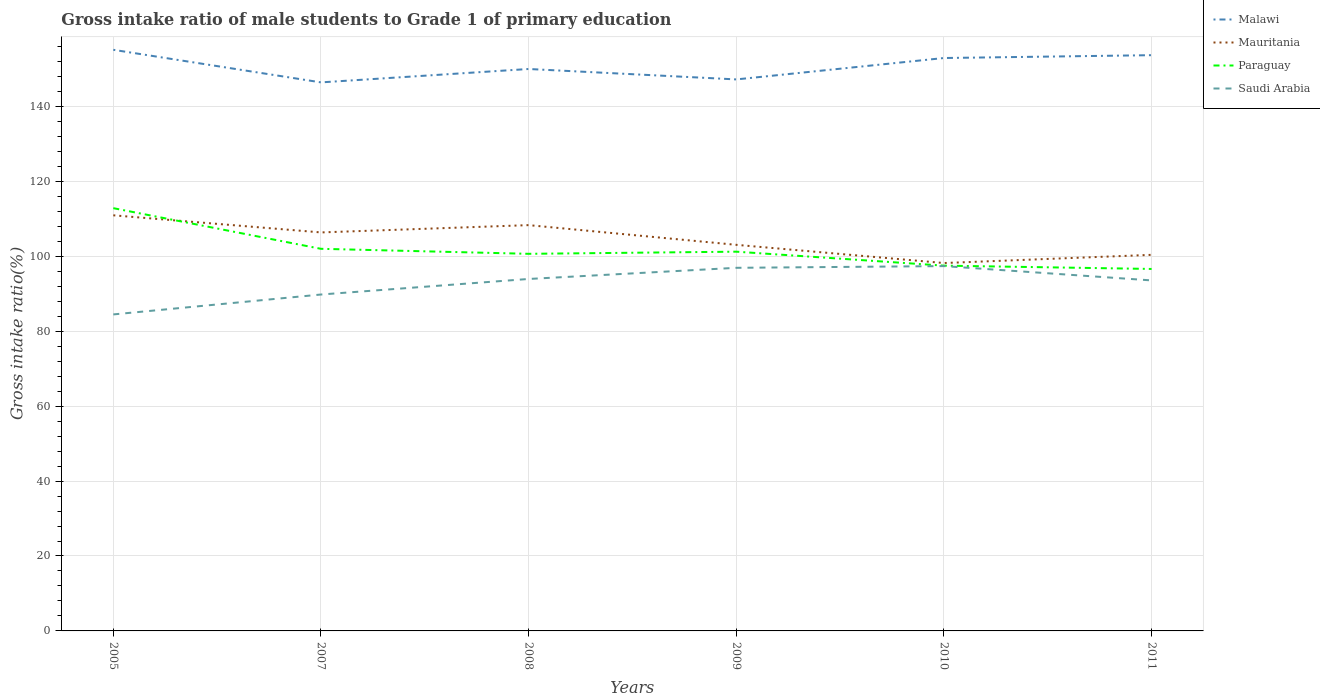How many different coloured lines are there?
Provide a succinct answer. 4. Is the number of lines equal to the number of legend labels?
Make the answer very short. Yes. Across all years, what is the maximum gross intake ratio in Mauritania?
Your response must be concise. 98.2. In which year was the gross intake ratio in Saudi Arabia maximum?
Offer a terse response. 2005. What is the total gross intake ratio in Mauritania in the graph?
Provide a succinct answer. 12.74. What is the difference between the highest and the second highest gross intake ratio in Paraguay?
Provide a succinct answer. 16.23. Is the gross intake ratio in Paraguay strictly greater than the gross intake ratio in Malawi over the years?
Your answer should be very brief. Yes. Does the graph contain any zero values?
Your answer should be very brief. No. How many legend labels are there?
Your response must be concise. 4. What is the title of the graph?
Your answer should be very brief. Gross intake ratio of male students to Grade 1 of primary education. What is the label or title of the X-axis?
Your response must be concise. Years. What is the label or title of the Y-axis?
Your answer should be very brief. Gross intake ratio(%). What is the Gross intake ratio(%) in Malawi in 2005?
Provide a short and direct response. 155.12. What is the Gross intake ratio(%) of Mauritania in 2005?
Offer a terse response. 110.94. What is the Gross intake ratio(%) in Paraguay in 2005?
Make the answer very short. 112.85. What is the Gross intake ratio(%) of Saudi Arabia in 2005?
Make the answer very short. 84.49. What is the Gross intake ratio(%) of Malawi in 2007?
Keep it short and to the point. 146.43. What is the Gross intake ratio(%) in Mauritania in 2007?
Your answer should be compact. 106.37. What is the Gross intake ratio(%) of Paraguay in 2007?
Make the answer very short. 102. What is the Gross intake ratio(%) in Saudi Arabia in 2007?
Give a very brief answer. 89.8. What is the Gross intake ratio(%) in Malawi in 2008?
Your answer should be very brief. 150. What is the Gross intake ratio(%) of Mauritania in 2008?
Make the answer very short. 108.32. What is the Gross intake ratio(%) in Paraguay in 2008?
Your response must be concise. 100.66. What is the Gross intake ratio(%) of Saudi Arabia in 2008?
Ensure brevity in your answer.  93.95. What is the Gross intake ratio(%) of Malawi in 2009?
Provide a succinct answer. 147.22. What is the Gross intake ratio(%) in Mauritania in 2009?
Offer a terse response. 103.06. What is the Gross intake ratio(%) of Paraguay in 2009?
Provide a short and direct response. 101.24. What is the Gross intake ratio(%) of Saudi Arabia in 2009?
Your answer should be very brief. 96.93. What is the Gross intake ratio(%) in Malawi in 2010?
Your answer should be very brief. 152.93. What is the Gross intake ratio(%) of Mauritania in 2010?
Your answer should be very brief. 98.2. What is the Gross intake ratio(%) of Paraguay in 2010?
Provide a succinct answer. 97.51. What is the Gross intake ratio(%) in Saudi Arabia in 2010?
Offer a terse response. 97.39. What is the Gross intake ratio(%) of Malawi in 2011?
Give a very brief answer. 153.69. What is the Gross intake ratio(%) of Mauritania in 2011?
Offer a terse response. 100.39. What is the Gross intake ratio(%) of Paraguay in 2011?
Provide a succinct answer. 96.62. What is the Gross intake ratio(%) in Saudi Arabia in 2011?
Keep it short and to the point. 93.56. Across all years, what is the maximum Gross intake ratio(%) of Malawi?
Ensure brevity in your answer.  155.12. Across all years, what is the maximum Gross intake ratio(%) of Mauritania?
Give a very brief answer. 110.94. Across all years, what is the maximum Gross intake ratio(%) in Paraguay?
Provide a short and direct response. 112.85. Across all years, what is the maximum Gross intake ratio(%) in Saudi Arabia?
Offer a very short reply. 97.39. Across all years, what is the minimum Gross intake ratio(%) in Malawi?
Provide a short and direct response. 146.43. Across all years, what is the minimum Gross intake ratio(%) of Mauritania?
Keep it short and to the point. 98.2. Across all years, what is the minimum Gross intake ratio(%) in Paraguay?
Make the answer very short. 96.62. Across all years, what is the minimum Gross intake ratio(%) in Saudi Arabia?
Give a very brief answer. 84.49. What is the total Gross intake ratio(%) in Malawi in the graph?
Make the answer very short. 905.38. What is the total Gross intake ratio(%) in Mauritania in the graph?
Give a very brief answer. 627.3. What is the total Gross intake ratio(%) in Paraguay in the graph?
Provide a short and direct response. 610.88. What is the total Gross intake ratio(%) in Saudi Arabia in the graph?
Give a very brief answer. 556.11. What is the difference between the Gross intake ratio(%) of Malawi in 2005 and that in 2007?
Give a very brief answer. 8.7. What is the difference between the Gross intake ratio(%) in Mauritania in 2005 and that in 2007?
Your response must be concise. 4.57. What is the difference between the Gross intake ratio(%) in Paraguay in 2005 and that in 2007?
Your answer should be compact. 10.85. What is the difference between the Gross intake ratio(%) in Saudi Arabia in 2005 and that in 2007?
Ensure brevity in your answer.  -5.31. What is the difference between the Gross intake ratio(%) in Malawi in 2005 and that in 2008?
Your response must be concise. 5.12. What is the difference between the Gross intake ratio(%) in Mauritania in 2005 and that in 2008?
Your answer should be very brief. 2.62. What is the difference between the Gross intake ratio(%) of Paraguay in 2005 and that in 2008?
Provide a short and direct response. 12.19. What is the difference between the Gross intake ratio(%) of Saudi Arabia in 2005 and that in 2008?
Your answer should be compact. -9.46. What is the difference between the Gross intake ratio(%) of Malawi in 2005 and that in 2009?
Ensure brevity in your answer.  7.91. What is the difference between the Gross intake ratio(%) of Mauritania in 2005 and that in 2009?
Offer a terse response. 7.88. What is the difference between the Gross intake ratio(%) of Paraguay in 2005 and that in 2009?
Give a very brief answer. 11.62. What is the difference between the Gross intake ratio(%) in Saudi Arabia in 2005 and that in 2009?
Offer a terse response. -12.44. What is the difference between the Gross intake ratio(%) in Malawi in 2005 and that in 2010?
Keep it short and to the point. 2.19. What is the difference between the Gross intake ratio(%) in Mauritania in 2005 and that in 2010?
Ensure brevity in your answer.  12.74. What is the difference between the Gross intake ratio(%) of Paraguay in 2005 and that in 2010?
Your response must be concise. 15.34. What is the difference between the Gross intake ratio(%) of Saudi Arabia in 2005 and that in 2010?
Provide a succinct answer. -12.9. What is the difference between the Gross intake ratio(%) of Malawi in 2005 and that in 2011?
Your answer should be compact. 1.43. What is the difference between the Gross intake ratio(%) in Mauritania in 2005 and that in 2011?
Offer a very short reply. 10.55. What is the difference between the Gross intake ratio(%) of Paraguay in 2005 and that in 2011?
Your answer should be compact. 16.23. What is the difference between the Gross intake ratio(%) of Saudi Arabia in 2005 and that in 2011?
Give a very brief answer. -9.08. What is the difference between the Gross intake ratio(%) in Malawi in 2007 and that in 2008?
Offer a terse response. -3.58. What is the difference between the Gross intake ratio(%) in Mauritania in 2007 and that in 2008?
Offer a terse response. -1.95. What is the difference between the Gross intake ratio(%) in Paraguay in 2007 and that in 2008?
Keep it short and to the point. 1.34. What is the difference between the Gross intake ratio(%) of Saudi Arabia in 2007 and that in 2008?
Your response must be concise. -4.15. What is the difference between the Gross intake ratio(%) in Malawi in 2007 and that in 2009?
Give a very brief answer. -0.79. What is the difference between the Gross intake ratio(%) in Mauritania in 2007 and that in 2009?
Give a very brief answer. 3.31. What is the difference between the Gross intake ratio(%) of Paraguay in 2007 and that in 2009?
Provide a short and direct response. 0.77. What is the difference between the Gross intake ratio(%) in Saudi Arabia in 2007 and that in 2009?
Provide a short and direct response. -7.13. What is the difference between the Gross intake ratio(%) in Malawi in 2007 and that in 2010?
Offer a terse response. -6.5. What is the difference between the Gross intake ratio(%) of Mauritania in 2007 and that in 2010?
Your answer should be compact. 8.17. What is the difference between the Gross intake ratio(%) of Paraguay in 2007 and that in 2010?
Your answer should be compact. 4.49. What is the difference between the Gross intake ratio(%) of Saudi Arabia in 2007 and that in 2010?
Make the answer very short. -7.59. What is the difference between the Gross intake ratio(%) in Malawi in 2007 and that in 2011?
Make the answer very short. -7.26. What is the difference between the Gross intake ratio(%) in Mauritania in 2007 and that in 2011?
Keep it short and to the point. 5.98. What is the difference between the Gross intake ratio(%) of Paraguay in 2007 and that in 2011?
Give a very brief answer. 5.38. What is the difference between the Gross intake ratio(%) of Saudi Arabia in 2007 and that in 2011?
Provide a succinct answer. -3.76. What is the difference between the Gross intake ratio(%) of Malawi in 2008 and that in 2009?
Your answer should be very brief. 2.78. What is the difference between the Gross intake ratio(%) in Mauritania in 2008 and that in 2009?
Ensure brevity in your answer.  5.26. What is the difference between the Gross intake ratio(%) of Paraguay in 2008 and that in 2009?
Make the answer very short. -0.57. What is the difference between the Gross intake ratio(%) in Saudi Arabia in 2008 and that in 2009?
Offer a very short reply. -2.98. What is the difference between the Gross intake ratio(%) of Malawi in 2008 and that in 2010?
Your answer should be compact. -2.93. What is the difference between the Gross intake ratio(%) of Mauritania in 2008 and that in 2010?
Offer a terse response. 10.12. What is the difference between the Gross intake ratio(%) of Paraguay in 2008 and that in 2010?
Give a very brief answer. 3.16. What is the difference between the Gross intake ratio(%) of Saudi Arabia in 2008 and that in 2010?
Your answer should be very brief. -3.44. What is the difference between the Gross intake ratio(%) of Malawi in 2008 and that in 2011?
Your answer should be compact. -3.69. What is the difference between the Gross intake ratio(%) in Mauritania in 2008 and that in 2011?
Make the answer very short. 7.93. What is the difference between the Gross intake ratio(%) in Paraguay in 2008 and that in 2011?
Your answer should be very brief. 4.04. What is the difference between the Gross intake ratio(%) of Saudi Arabia in 2008 and that in 2011?
Your response must be concise. 0.39. What is the difference between the Gross intake ratio(%) in Malawi in 2009 and that in 2010?
Your answer should be very brief. -5.71. What is the difference between the Gross intake ratio(%) of Mauritania in 2009 and that in 2010?
Offer a terse response. 4.86. What is the difference between the Gross intake ratio(%) of Paraguay in 2009 and that in 2010?
Your response must be concise. 3.73. What is the difference between the Gross intake ratio(%) of Saudi Arabia in 2009 and that in 2010?
Make the answer very short. -0.46. What is the difference between the Gross intake ratio(%) of Malawi in 2009 and that in 2011?
Your answer should be very brief. -6.47. What is the difference between the Gross intake ratio(%) in Mauritania in 2009 and that in 2011?
Offer a terse response. 2.67. What is the difference between the Gross intake ratio(%) in Paraguay in 2009 and that in 2011?
Keep it short and to the point. 4.61. What is the difference between the Gross intake ratio(%) in Saudi Arabia in 2009 and that in 2011?
Provide a succinct answer. 3.36. What is the difference between the Gross intake ratio(%) in Malawi in 2010 and that in 2011?
Your answer should be very brief. -0.76. What is the difference between the Gross intake ratio(%) of Mauritania in 2010 and that in 2011?
Provide a short and direct response. -2.19. What is the difference between the Gross intake ratio(%) in Paraguay in 2010 and that in 2011?
Provide a succinct answer. 0.88. What is the difference between the Gross intake ratio(%) of Saudi Arabia in 2010 and that in 2011?
Your answer should be compact. 3.82. What is the difference between the Gross intake ratio(%) of Malawi in 2005 and the Gross intake ratio(%) of Mauritania in 2007?
Make the answer very short. 48.75. What is the difference between the Gross intake ratio(%) in Malawi in 2005 and the Gross intake ratio(%) in Paraguay in 2007?
Provide a succinct answer. 53.12. What is the difference between the Gross intake ratio(%) of Malawi in 2005 and the Gross intake ratio(%) of Saudi Arabia in 2007?
Keep it short and to the point. 65.32. What is the difference between the Gross intake ratio(%) in Mauritania in 2005 and the Gross intake ratio(%) in Paraguay in 2007?
Your answer should be very brief. 8.94. What is the difference between the Gross intake ratio(%) of Mauritania in 2005 and the Gross intake ratio(%) of Saudi Arabia in 2007?
Offer a terse response. 21.14. What is the difference between the Gross intake ratio(%) in Paraguay in 2005 and the Gross intake ratio(%) in Saudi Arabia in 2007?
Provide a succinct answer. 23.05. What is the difference between the Gross intake ratio(%) in Malawi in 2005 and the Gross intake ratio(%) in Mauritania in 2008?
Provide a short and direct response. 46.8. What is the difference between the Gross intake ratio(%) in Malawi in 2005 and the Gross intake ratio(%) in Paraguay in 2008?
Offer a terse response. 54.46. What is the difference between the Gross intake ratio(%) of Malawi in 2005 and the Gross intake ratio(%) of Saudi Arabia in 2008?
Provide a short and direct response. 61.17. What is the difference between the Gross intake ratio(%) in Mauritania in 2005 and the Gross intake ratio(%) in Paraguay in 2008?
Your response must be concise. 10.28. What is the difference between the Gross intake ratio(%) of Mauritania in 2005 and the Gross intake ratio(%) of Saudi Arabia in 2008?
Offer a terse response. 16.99. What is the difference between the Gross intake ratio(%) of Paraguay in 2005 and the Gross intake ratio(%) of Saudi Arabia in 2008?
Offer a very short reply. 18.9. What is the difference between the Gross intake ratio(%) of Malawi in 2005 and the Gross intake ratio(%) of Mauritania in 2009?
Provide a succinct answer. 52.06. What is the difference between the Gross intake ratio(%) of Malawi in 2005 and the Gross intake ratio(%) of Paraguay in 2009?
Your answer should be compact. 53.89. What is the difference between the Gross intake ratio(%) in Malawi in 2005 and the Gross intake ratio(%) in Saudi Arabia in 2009?
Offer a very short reply. 58.19. What is the difference between the Gross intake ratio(%) in Mauritania in 2005 and the Gross intake ratio(%) in Paraguay in 2009?
Offer a very short reply. 9.71. What is the difference between the Gross intake ratio(%) in Mauritania in 2005 and the Gross intake ratio(%) in Saudi Arabia in 2009?
Keep it short and to the point. 14.02. What is the difference between the Gross intake ratio(%) of Paraguay in 2005 and the Gross intake ratio(%) of Saudi Arabia in 2009?
Your response must be concise. 15.92. What is the difference between the Gross intake ratio(%) in Malawi in 2005 and the Gross intake ratio(%) in Mauritania in 2010?
Give a very brief answer. 56.92. What is the difference between the Gross intake ratio(%) of Malawi in 2005 and the Gross intake ratio(%) of Paraguay in 2010?
Provide a succinct answer. 57.62. What is the difference between the Gross intake ratio(%) in Malawi in 2005 and the Gross intake ratio(%) in Saudi Arabia in 2010?
Your answer should be compact. 57.74. What is the difference between the Gross intake ratio(%) in Mauritania in 2005 and the Gross intake ratio(%) in Paraguay in 2010?
Offer a terse response. 13.44. What is the difference between the Gross intake ratio(%) in Mauritania in 2005 and the Gross intake ratio(%) in Saudi Arabia in 2010?
Your answer should be very brief. 13.56. What is the difference between the Gross intake ratio(%) in Paraguay in 2005 and the Gross intake ratio(%) in Saudi Arabia in 2010?
Provide a short and direct response. 15.46. What is the difference between the Gross intake ratio(%) in Malawi in 2005 and the Gross intake ratio(%) in Mauritania in 2011?
Provide a short and direct response. 54.73. What is the difference between the Gross intake ratio(%) of Malawi in 2005 and the Gross intake ratio(%) of Paraguay in 2011?
Ensure brevity in your answer.  58.5. What is the difference between the Gross intake ratio(%) in Malawi in 2005 and the Gross intake ratio(%) in Saudi Arabia in 2011?
Make the answer very short. 61.56. What is the difference between the Gross intake ratio(%) of Mauritania in 2005 and the Gross intake ratio(%) of Paraguay in 2011?
Offer a terse response. 14.32. What is the difference between the Gross intake ratio(%) in Mauritania in 2005 and the Gross intake ratio(%) in Saudi Arabia in 2011?
Offer a very short reply. 17.38. What is the difference between the Gross intake ratio(%) in Paraguay in 2005 and the Gross intake ratio(%) in Saudi Arabia in 2011?
Provide a short and direct response. 19.29. What is the difference between the Gross intake ratio(%) of Malawi in 2007 and the Gross intake ratio(%) of Mauritania in 2008?
Your answer should be very brief. 38.1. What is the difference between the Gross intake ratio(%) of Malawi in 2007 and the Gross intake ratio(%) of Paraguay in 2008?
Provide a succinct answer. 45.76. What is the difference between the Gross intake ratio(%) in Malawi in 2007 and the Gross intake ratio(%) in Saudi Arabia in 2008?
Ensure brevity in your answer.  52.48. What is the difference between the Gross intake ratio(%) in Mauritania in 2007 and the Gross intake ratio(%) in Paraguay in 2008?
Provide a short and direct response. 5.71. What is the difference between the Gross intake ratio(%) in Mauritania in 2007 and the Gross intake ratio(%) in Saudi Arabia in 2008?
Keep it short and to the point. 12.42. What is the difference between the Gross intake ratio(%) of Paraguay in 2007 and the Gross intake ratio(%) of Saudi Arabia in 2008?
Your answer should be very brief. 8.05. What is the difference between the Gross intake ratio(%) of Malawi in 2007 and the Gross intake ratio(%) of Mauritania in 2009?
Make the answer very short. 43.36. What is the difference between the Gross intake ratio(%) in Malawi in 2007 and the Gross intake ratio(%) in Paraguay in 2009?
Make the answer very short. 45.19. What is the difference between the Gross intake ratio(%) of Malawi in 2007 and the Gross intake ratio(%) of Saudi Arabia in 2009?
Offer a terse response. 49.5. What is the difference between the Gross intake ratio(%) in Mauritania in 2007 and the Gross intake ratio(%) in Paraguay in 2009?
Make the answer very short. 5.14. What is the difference between the Gross intake ratio(%) in Mauritania in 2007 and the Gross intake ratio(%) in Saudi Arabia in 2009?
Give a very brief answer. 9.45. What is the difference between the Gross intake ratio(%) in Paraguay in 2007 and the Gross intake ratio(%) in Saudi Arabia in 2009?
Make the answer very short. 5.07. What is the difference between the Gross intake ratio(%) of Malawi in 2007 and the Gross intake ratio(%) of Mauritania in 2010?
Your response must be concise. 48.22. What is the difference between the Gross intake ratio(%) in Malawi in 2007 and the Gross intake ratio(%) in Paraguay in 2010?
Provide a succinct answer. 48.92. What is the difference between the Gross intake ratio(%) of Malawi in 2007 and the Gross intake ratio(%) of Saudi Arabia in 2010?
Your answer should be very brief. 49.04. What is the difference between the Gross intake ratio(%) of Mauritania in 2007 and the Gross intake ratio(%) of Paraguay in 2010?
Provide a short and direct response. 8.87. What is the difference between the Gross intake ratio(%) of Mauritania in 2007 and the Gross intake ratio(%) of Saudi Arabia in 2010?
Offer a terse response. 8.99. What is the difference between the Gross intake ratio(%) of Paraguay in 2007 and the Gross intake ratio(%) of Saudi Arabia in 2010?
Keep it short and to the point. 4.61. What is the difference between the Gross intake ratio(%) of Malawi in 2007 and the Gross intake ratio(%) of Mauritania in 2011?
Your answer should be compact. 46.03. What is the difference between the Gross intake ratio(%) in Malawi in 2007 and the Gross intake ratio(%) in Paraguay in 2011?
Provide a succinct answer. 49.8. What is the difference between the Gross intake ratio(%) in Malawi in 2007 and the Gross intake ratio(%) in Saudi Arabia in 2011?
Keep it short and to the point. 52.86. What is the difference between the Gross intake ratio(%) in Mauritania in 2007 and the Gross intake ratio(%) in Paraguay in 2011?
Provide a short and direct response. 9.75. What is the difference between the Gross intake ratio(%) of Mauritania in 2007 and the Gross intake ratio(%) of Saudi Arabia in 2011?
Your answer should be very brief. 12.81. What is the difference between the Gross intake ratio(%) of Paraguay in 2007 and the Gross intake ratio(%) of Saudi Arabia in 2011?
Ensure brevity in your answer.  8.44. What is the difference between the Gross intake ratio(%) in Malawi in 2008 and the Gross intake ratio(%) in Mauritania in 2009?
Offer a terse response. 46.94. What is the difference between the Gross intake ratio(%) in Malawi in 2008 and the Gross intake ratio(%) in Paraguay in 2009?
Make the answer very short. 48.77. What is the difference between the Gross intake ratio(%) in Malawi in 2008 and the Gross intake ratio(%) in Saudi Arabia in 2009?
Provide a short and direct response. 53.07. What is the difference between the Gross intake ratio(%) in Mauritania in 2008 and the Gross intake ratio(%) in Paraguay in 2009?
Your answer should be compact. 7.09. What is the difference between the Gross intake ratio(%) in Mauritania in 2008 and the Gross intake ratio(%) in Saudi Arabia in 2009?
Provide a short and direct response. 11.39. What is the difference between the Gross intake ratio(%) of Paraguay in 2008 and the Gross intake ratio(%) of Saudi Arabia in 2009?
Make the answer very short. 3.74. What is the difference between the Gross intake ratio(%) of Malawi in 2008 and the Gross intake ratio(%) of Mauritania in 2010?
Your answer should be compact. 51.8. What is the difference between the Gross intake ratio(%) of Malawi in 2008 and the Gross intake ratio(%) of Paraguay in 2010?
Offer a terse response. 52.49. What is the difference between the Gross intake ratio(%) of Malawi in 2008 and the Gross intake ratio(%) of Saudi Arabia in 2010?
Offer a very short reply. 52.62. What is the difference between the Gross intake ratio(%) of Mauritania in 2008 and the Gross intake ratio(%) of Paraguay in 2010?
Offer a very short reply. 10.82. What is the difference between the Gross intake ratio(%) of Mauritania in 2008 and the Gross intake ratio(%) of Saudi Arabia in 2010?
Make the answer very short. 10.94. What is the difference between the Gross intake ratio(%) of Paraguay in 2008 and the Gross intake ratio(%) of Saudi Arabia in 2010?
Your answer should be very brief. 3.28. What is the difference between the Gross intake ratio(%) of Malawi in 2008 and the Gross intake ratio(%) of Mauritania in 2011?
Ensure brevity in your answer.  49.61. What is the difference between the Gross intake ratio(%) of Malawi in 2008 and the Gross intake ratio(%) of Paraguay in 2011?
Provide a short and direct response. 53.38. What is the difference between the Gross intake ratio(%) in Malawi in 2008 and the Gross intake ratio(%) in Saudi Arabia in 2011?
Keep it short and to the point. 56.44. What is the difference between the Gross intake ratio(%) of Mauritania in 2008 and the Gross intake ratio(%) of Paraguay in 2011?
Give a very brief answer. 11.7. What is the difference between the Gross intake ratio(%) in Mauritania in 2008 and the Gross intake ratio(%) in Saudi Arabia in 2011?
Your response must be concise. 14.76. What is the difference between the Gross intake ratio(%) of Paraguay in 2008 and the Gross intake ratio(%) of Saudi Arabia in 2011?
Make the answer very short. 7.1. What is the difference between the Gross intake ratio(%) in Malawi in 2009 and the Gross intake ratio(%) in Mauritania in 2010?
Keep it short and to the point. 49.01. What is the difference between the Gross intake ratio(%) of Malawi in 2009 and the Gross intake ratio(%) of Paraguay in 2010?
Ensure brevity in your answer.  49.71. What is the difference between the Gross intake ratio(%) in Malawi in 2009 and the Gross intake ratio(%) in Saudi Arabia in 2010?
Provide a short and direct response. 49.83. What is the difference between the Gross intake ratio(%) of Mauritania in 2009 and the Gross intake ratio(%) of Paraguay in 2010?
Offer a terse response. 5.56. What is the difference between the Gross intake ratio(%) in Mauritania in 2009 and the Gross intake ratio(%) in Saudi Arabia in 2010?
Your response must be concise. 5.68. What is the difference between the Gross intake ratio(%) in Paraguay in 2009 and the Gross intake ratio(%) in Saudi Arabia in 2010?
Your response must be concise. 3.85. What is the difference between the Gross intake ratio(%) in Malawi in 2009 and the Gross intake ratio(%) in Mauritania in 2011?
Ensure brevity in your answer.  46.83. What is the difference between the Gross intake ratio(%) in Malawi in 2009 and the Gross intake ratio(%) in Paraguay in 2011?
Offer a terse response. 50.59. What is the difference between the Gross intake ratio(%) in Malawi in 2009 and the Gross intake ratio(%) in Saudi Arabia in 2011?
Keep it short and to the point. 53.65. What is the difference between the Gross intake ratio(%) of Mauritania in 2009 and the Gross intake ratio(%) of Paraguay in 2011?
Provide a succinct answer. 6.44. What is the difference between the Gross intake ratio(%) in Mauritania in 2009 and the Gross intake ratio(%) in Saudi Arabia in 2011?
Your response must be concise. 9.5. What is the difference between the Gross intake ratio(%) in Paraguay in 2009 and the Gross intake ratio(%) in Saudi Arabia in 2011?
Provide a succinct answer. 7.67. What is the difference between the Gross intake ratio(%) of Malawi in 2010 and the Gross intake ratio(%) of Mauritania in 2011?
Make the answer very short. 52.54. What is the difference between the Gross intake ratio(%) of Malawi in 2010 and the Gross intake ratio(%) of Paraguay in 2011?
Your response must be concise. 56.31. What is the difference between the Gross intake ratio(%) in Malawi in 2010 and the Gross intake ratio(%) in Saudi Arabia in 2011?
Make the answer very short. 59.37. What is the difference between the Gross intake ratio(%) of Mauritania in 2010 and the Gross intake ratio(%) of Paraguay in 2011?
Offer a very short reply. 1.58. What is the difference between the Gross intake ratio(%) in Mauritania in 2010 and the Gross intake ratio(%) in Saudi Arabia in 2011?
Ensure brevity in your answer.  4.64. What is the difference between the Gross intake ratio(%) in Paraguay in 2010 and the Gross intake ratio(%) in Saudi Arabia in 2011?
Your answer should be very brief. 3.94. What is the average Gross intake ratio(%) in Malawi per year?
Offer a terse response. 150.9. What is the average Gross intake ratio(%) in Mauritania per year?
Your answer should be very brief. 104.55. What is the average Gross intake ratio(%) of Paraguay per year?
Offer a terse response. 101.81. What is the average Gross intake ratio(%) of Saudi Arabia per year?
Provide a succinct answer. 92.69. In the year 2005, what is the difference between the Gross intake ratio(%) of Malawi and Gross intake ratio(%) of Mauritania?
Your answer should be very brief. 44.18. In the year 2005, what is the difference between the Gross intake ratio(%) in Malawi and Gross intake ratio(%) in Paraguay?
Provide a succinct answer. 42.27. In the year 2005, what is the difference between the Gross intake ratio(%) of Malawi and Gross intake ratio(%) of Saudi Arabia?
Keep it short and to the point. 70.64. In the year 2005, what is the difference between the Gross intake ratio(%) of Mauritania and Gross intake ratio(%) of Paraguay?
Offer a terse response. -1.91. In the year 2005, what is the difference between the Gross intake ratio(%) of Mauritania and Gross intake ratio(%) of Saudi Arabia?
Your response must be concise. 26.46. In the year 2005, what is the difference between the Gross intake ratio(%) of Paraguay and Gross intake ratio(%) of Saudi Arabia?
Keep it short and to the point. 28.36. In the year 2007, what is the difference between the Gross intake ratio(%) of Malawi and Gross intake ratio(%) of Mauritania?
Provide a succinct answer. 40.05. In the year 2007, what is the difference between the Gross intake ratio(%) of Malawi and Gross intake ratio(%) of Paraguay?
Offer a terse response. 44.42. In the year 2007, what is the difference between the Gross intake ratio(%) in Malawi and Gross intake ratio(%) in Saudi Arabia?
Your response must be concise. 56.63. In the year 2007, what is the difference between the Gross intake ratio(%) in Mauritania and Gross intake ratio(%) in Paraguay?
Provide a short and direct response. 4.37. In the year 2007, what is the difference between the Gross intake ratio(%) in Mauritania and Gross intake ratio(%) in Saudi Arabia?
Give a very brief answer. 16.57. In the year 2007, what is the difference between the Gross intake ratio(%) in Paraguay and Gross intake ratio(%) in Saudi Arabia?
Provide a succinct answer. 12.2. In the year 2008, what is the difference between the Gross intake ratio(%) of Malawi and Gross intake ratio(%) of Mauritania?
Offer a very short reply. 41.68. In the year 2008, what is the difference between the Gross intake ratio(%) of Malawi and Gross intake ratio(%) of Paraguay?
Keep it short and to the point. 49.34. In the year 2008, what is the difference between the Gross intake ratio(%) in Malawi and Gross intake ratio(%) in Saudi Arabia?
Your response must be concise. 56.05. In the year 2008, what is the difference between the Gross intake ratio(%) of Mauritania and Gross intake ratio(%) of Paraguay?
Offer a terse response. 7.66. In the year 2008, what is the difference between the Gross intake ratio(%) in Mauritania and Gross intake ratio(%) in Saudi Arabia?
Make the answer very short. 14.37. In the year 2008, what is the difference between the Gross intake ratio(%) in Paraguay and Gross intake ratio(%) in Saudi Arabia?
Offer a very short reply. 6.71. In the year 2009, what is the difference between the Gross intake ratio(%) of Malawi and Gross intake ratio(%) of Mauritania?
Ensure brevity in your answer.  44.15. In the year 2009, what is the difference between the Gross intake ratio(%) in Malawi and Gross intake ratio(%) in Paraguay?
Offer a terse response. 45.98. In the year 2009, what is the difference between the Gross intake ratio(%) of Malawi and Gross intake ratio(%) of Saudi Arabia?
Make the answer very short. 50.29. In the year 2009, what is the difference between the Gross intake ratio(%) of Mauritania and Gross intake ratio(%) of Paraguay?
Provide a short and direct response. 1.83. In the year 2009, what is the difference between the Gross intake ratio(%) of Mauritania and Gross intake ratio(%) of Saudi Arabia?
Your answer should be very brief. 6.14. In the year 2009, what is the difference between the Gross intake ratio(%) in Paraguay and Gross intake ratio(%) in Saudi Arabia?
Your answer should be very brief. 4.31. In the year 2010, what is the difference between the Gross intake ratio(%) of Malawi and Gross intake ratio(%) of Mauritania?
Your answer should be very brief. 54.73. In the year 2010, what is the difference between the Gross intake ratio(%) of Malawi and Gross intake ratio(%) of Paraguay?
Your answer should be compact. 55.42. In the year 2010, what is the difference between the Gross intake ratio(%) of Malawi and Gross intake ratio(%) of Saudi Arabia?
Provide a short and direct response. 55.54. In the year 2010, what is the difference between the Gross intake ratio(%) of Mauritania and Gross intake ratio(%) of Paraguay?
Give a very brief answer. 0.7. In the year 2010, what is the difference between the Gross intake ratio(%) of Mauritania and Gross intake ratio(%) of Saudi Arabia?
Ensure brevity in your answer.  0.82. In the year 2010, what is the difference between the Gross intake ratio(%) in Paraguay and Gross intake ratio(%) in Saudi Arabia?
Offer a terse response. 0.12. In the year 2011, what is the difference between the Gross intake ratio(%) of Malawi and Gross intake ratio(%) of Mauritania?
Offer a terse response. 53.3. In the year 2011, what is the difference between the Gross intake ratio(%) in Malawi and Gross intake ratio(%) in Paraguay?
Offer a terse response. 57.07. In the year 2011, what is the difference between the Gross intake ratio(%) of Malawi and Gross intake ratio(%) of Saudi Arabia?
Your answer should be compact. 60.12. In the year 2011, what is the difference between the Gross intake ratio(%) of Mauritania and Gross intake ratio(%) of Paraguay?
Ensure brevity in your answer.  3.77. In the year 2011, what is the difference between the Gross intake ratio(%) in Mauritania and Gross intake ratio(%) in Saudi Arabia?
Keep it short and to the point. 6.83. In the year 2011, what is the difference between the Gross intake ratio(%) of Paraguay and Gross intake ratio(%) of Saudi Arabia?
Keep it short and to the point. 3.06. What is the ratio of the Gross intake ratio(%) of Malawi in 2005 to that in 2007?
Offer a terse response. 1.06. What is the ratio of the Gross intake ratio(%) in Mauritania in 2005 to that in 2007?
Your answer should be compact. 1.04. What is the ratio of the Gross intake ratio(%) of Paraguay in 2005 to that in 2007?
Your answer should be very brief. 1.11. What is the ratio of the Gross intake ratio(%) in Saudi Arabia in 2005 to that in 2007?
Give a very brief answer. 0.94. What is the ratio of the Gross intake ratio(%) in Malawi in 2005 to that in 2008?
Your answer should be very brief. 1.03. What is the ratio of the Gross intake ratio(%) in Mauritania in 2005 to that in 2008?
Offer a very short reply. 1.02. What is the ratio of the Gross intake ratio(%) in Paraguay in 2005 to that in 2008?
Your answer should be compact. 1.12. What is the ratio of the Gross intake ratio(%) of Saudi Arabia in 2005 to that in 2008?
Keep it short and to the point. 0.9. What is the ratio of the Gross intake ratio(%) in Malawi in 2005 to that in 2009?
Offer a terse response. 1.05. What is the ratio of the Gross intake ratio(%) of Mauritania in 2005 to that in 2009?
Give a very brief answer. 1.08. What is the ratio of the Gross intake ratio(%) of Paraguay in 2005 to that in 2009?
Ensure brevity in your answer.  1.11. What is the ratio of the Gross intake ratio(%) in Saudi Arabia in 2005 to that in 2009?
Make the answer very short. 0.87. What is the ratio of the Gross intake ratio(%) of Malawi in 2005 to that in 2010?
Provide a short and direct response. 1.01. What is the ratio of the Gross intake ratio(%) of Mauritania in 2005 to that in 2010?
Ensure brevity in your answer.  1.13. What is the ratio of the Gross intake ratio(%) in Paraguay in 2005 to that in 2010?
Your answer should be compact. 1.16. What is the ratio of the Gross intake ratio(%) of Saudi Arabia in 2005 to that in 2010?
Ensure brevity in your answer.  0.87. What is the ratio of the Gross intake ratio(%) in Malawi in 2005 to that in 2011?
Ensure brevity in your answer.  1.01. What is the ratio of the Gross intake ratio(%) in Mauritania in 2005 to that in 2011?
Make the answer very short. 1.11. What is the ratio of the Gross intake ratio(%) of Paraguay in 2005 to that in 2011?
Your answer should be very brief. 1.17. What is the ratio of the Gross intake ratio(%) of Saudi Arabia in 2005 to that in 2011?
Your response must be concise. 0.9. What is the ratio of the Gross intake ratio(%) in Malawi in 2007 to that in 2008?
Offer a terse response. 0.98. What is the ratio of the Gross intake ratio(%) in Mauritania in 2007 to that in 2008?
Provide a short and direct response. 0.98. What is the ratio of the Gross intake ratio(%) in Paraguay in 2007 to that in 2008?
Give a very brief answer. 1.01. What is the ratio of the Gross intake ratio(%) of Saudi Arabia in 2007 to that in 2008?
Your response must be concise. 0.96. What is the ratio of the Gross intake ratio(%) of Malawi in 2007 to that in 2009?
Offer a terse response. 0.99. What is the ratio of the Gross intake ratio(%) of Mauritania in 2007 to that in 2009?
Give a very brief answer. 1.03. What is the ratio of the Gross intake ratio(%) of Paraguay in 2007 to that in 2009?
Ensure brevity in your answer.  1.01. What is the ratio of the Gross intake ratio(%) of Saudi Arabia in 2007 to that in 2009?
Offer a very short reply. 0.93. What is the ratio of the Gross intake ratio(%) in Malawi in 2007 to that in 2010?
Provide a succinct answer. 0.96. What is the ratio of the Gross intake ratio(%) in Mauritania in 2007 to that in 2010?
Your answer should be very brief. 1.08. What is the ratio of the Gross intake ratio(%) of Paraguay in 2007 to that in 2010?
Provide a short and direct response. 1.05. What is the ratio of the Gross intake ratio(%) of Saudi Arabia in 2007 to that in 2010?
Keep it short and to the point. 0.92. What is the ratio of the Gross intake ratio(%) in Malawi in 2007 to that in 2011?
Provide a succinct answer. 0.95. What is the ratio of the Gross intake ratio(%) of Mauritania in 2007 to that in 2011?
Make the answer very short. 1.06. What is the ratio of the Gross intake ratio(%) of Paraguay in 2007 to that in 2011?
Offer a terse response. 1.06. What is the ratio of the Gross intake ratio(%) of Saudi Arabia in 2007 to that in 2011?
Keep it short and to the point. 0.96. What is the ratio of the Gross intake ratio(%) of Malawi in 2008 to that in 2009?
Make the answer very short. 1.02. What is the ratio of the Gross intake ratio(%) of Mauritania in 2008 to that in 2009?
Provide a short and direct response. 1.05. What is the ratio of the Gross intake ratio(%) of Saudi Arabia in 2008 to that in 2009?
Your response must be concise. 0.97. What is the ratio of the Gross intake ratio(%) of Malawi in 2008 to that in 2010?
Your response must be concise. 0.98. What is the ratio of the Gross intake ratio(%) in Mauritania in 2008 to that in 2010?
Your answer should be compact. 1.1. What is the ratio of the Gross intake ratio(%) in Paraguay in 2008 to that in 2010?
Your answer should be compact. 1.03. What is the ratio of the Gross intake ratio(%) in Saudi Arabia in 2008 to that in 2010?
Give a very brief answer. 0.96. What is the ratio of the Gross intake ratio(%) of Mauritania in 2008 to that in 2011?
Offer a very short reply. 1.08. What is the ratio of the Gross intake ratio(%) of Paraguay in 2008 to that in 2011?
Provide a short and direct response. 1.04. What is the ratio of the Gross intake ratio(%) of Saudi Arabia in 2008 to that in 2011?
Provide a short and direct response. 1. What is the ratio of the Gross intake ratio(%) in Malawi in 2009 to that in 2010?
Offer a very short reply. 0.96. What is the ratio of the Gross intake ratio(%) of Mauritania in 2009 to that in 2010?
Give a very brief answer. 1.05. What is the ratio of the Gross intake ratio(%) of Paraguay in 2009 to that in 2010?
Ensure brevity in your answer.  1.04. What is the ratio of the Gross intake ratio(%) of Malawi in 2009 to that in 2011?
Make the answer very short. 0.96. What is the ratio of the Gross intake ratio(%) of Mauritania in 2009 to that in 2011?
Offer a very short reply. 1.03. What is the ratio of the Gross intake ratio(%) of Paraguay in 2009 to that in 2011?
Offer a terse response. 1.05. What is the ratio of the Gross intake ratio(%) of Saudi Arabia in 2009 to that in 2011?
Offer a very short reply. 1.04. What is the ratio of the Gross intake ratio(%) of Mauritania in 2010 to that in 2011?
Offer a terse response. 0.98. What is the ratio of the Gross intake ratio(%) in Paraguay in 2010 to that in 2011?
Provide a short and direct response. 1.01. What is the ratio of the Gross intake ratio(%) in Saudi Arabia in 2010 to that in 2011?
Your answer should be compact. 1.04. What is the difference between the highest and the second highest Gross intake ratio(%) in Malawi?
Your answer should be compact. 1.43. What is the difference between the highest and the second highest Gross intake ratio(%) in Mauritania?
Your answer should be compact. 2.62. What is the difference between the highest and the second highest Gross intake ratio(%) of Paraguay?
Your answer should be very brief. 10.85. What is the difference between the highest and the second highest Gross intake ratio(%) of Saudi Arabia?
Offer a terse response. 0.46. What is the difference between the highest and the lowest Gross intake ratio(%) in Malawi?
Your response must be concise. 8.7. What is the difference between the highest and the lowest Gross intake ratio(%) of Mauritania?
Offer a very short reply. 12.74. What is the difference between the highest and the lowest Gross intake ratio(%) in Paraguay?
Ensure brevity in your answer.  16.23. What is the difference between the highest and the lowest Gross intake ratio(%) in Saudi Arabia?
Offer a very short reply. 12.9. 